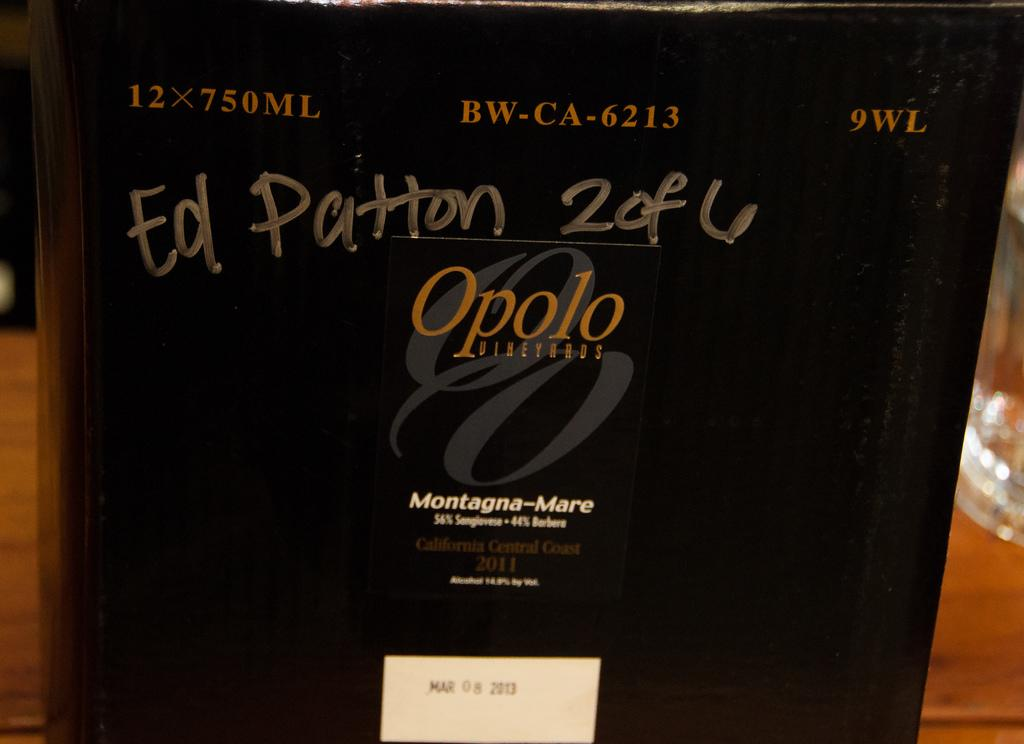<image>
Create a compact narrative representing the image presented. The name Ed Patton has been written on the side of a case of wine. 